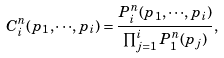<formula> <loc_0><loc_0><loc_500><loc_500>C _ { i } ^ { n } ( { p _ { 1 } } , \cdot \cdot \cdot , { p _ { i } } ) = \frac { P _ { i } ^ { n } ( { p _ { 1 } } , \cdot \cdot \cdot , { p _ { i } } ) } { \prod _ { j = 1 } ^ { i } P _ { 1 } ^ { n } ( { p _ { j } } ) } ,</formula> 